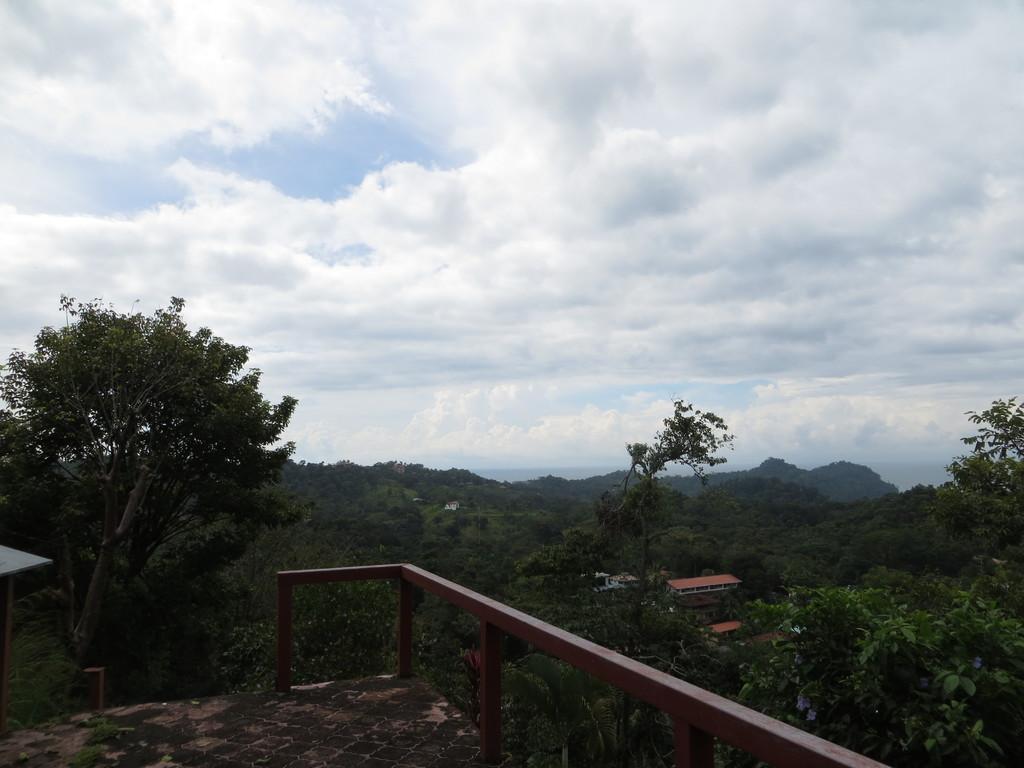What material is the floor made of in the image? The floor in the image is made of iron sheets. What can be seen in the image besides the floor? There is fencing, trees, houses, and a cloudy sky visible in the image. What type of vegetation is in the background of the image? There are trees in the background of the image. What type of structures are in the background of the image? There are houses in the background of the image. What is the condition of the sky in the image? The sky is cloudy at the top of the image. What scent can be detected from the sock in the image? There is no sock present in the image, so it is not possible to detect any scent. 